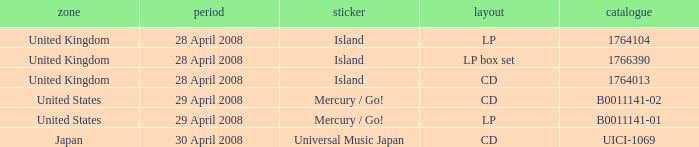What is the Label of the B0011141-01 Catalog? Mercury / Go!. Would you be able to parse every entry in this table? {'header': ['zone', 'period', 'sticker', 'layout', 'catalogue'], 'rows': [['United Kingdom', '28 April 2008', 'Island', 'LP', '1764104'], ['United Kingdom', '28 April 2008', 'Island', 'LP box set', '1766390'], ['United Kingdom', '28 April 2008', 'Island', 'CD', '1764013'], ['United States', '29 April 2008', 'Mercury / Go!', 'CD', 'B0011141-02'], ['United States', '29 April 2008', 'Mercury / Go!', 'LP', 'B0011141-01'], ['Japan', '30 April 2008', 'Universal Music Japan', 'CD', 'UICI-1069']]} 